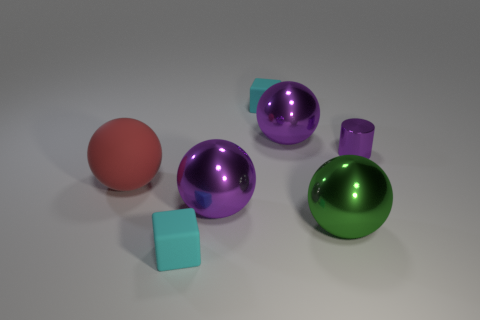Subtract all green balls. How many balls are left? 3 Subtract all red rubber balls. How many balls are left? 3 Subtract all yellow balls. Subtract all green blocks. How many balls are left? 4 Add 3 green objects. How many objects exist? 10 Subtract all cylinders. How many objects are left? 6 Add 3 small blocks. How many small blocks are left? 5 Add 6 brown matte cylinders. How many brown matte cylinders exist? 6 Subtract 0 blue cubes. How many objects are left? 7 Subtract all tiny yellow matte cylinders. Subtract all purple metal cylinders. How many objects are left? 6 